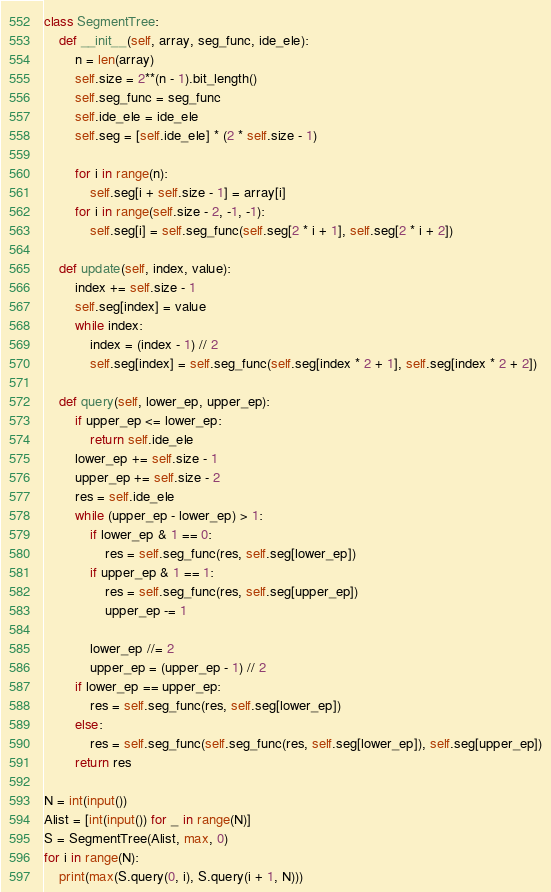<code> <loc_0><loc_0><loc_500><loc_500><_Python_>class SegmentTree:
    def __init__(self, array, seg_func, ide_ele):
        n = len(array)
        self.size = 2**(n - 1).bit_length()
        self.seg_func = seg_func
        self.ide_ele = ide_ele
        self.seg = [self.ide_ele] * (2 * self.size - 1)

        for i in range(n):
            self.seg[i + self.size - 1] = array[i]
        for i in range(self.size - 2, -1, -1):
            self.seg[i] = self.seg_func(self.seg[2 * i + 1], self.seg[2 * i + 2])

    def update(self, index, value):
        index += self.size - 1
        self.seg[index] = value
        while index:
            index = (index - 1) // 2
            self.seg[index] = self.seg_func(self.seg[index * 2 + 1], self.seg[index * 2 + 2])

    def query(self, lower_ep, upper_ep):
        if upper_ep <= lower_ep:
            return self.ide_ele
        lower_ep += self.size - 1
        upper_ep += self.size - 2
        res = self.ide_ele
        while (upper_ep - lower_ep) > 1:
            if lower_ep & 1 == 0:
                res = self.seg_func(res, self.seg[lower_ep])
            if upper_ep & 1 == 1:
                res = self.seg_func(res, self.seg[upper_ep])
                upper_ep -= 1

            lower_ep //= 2
            upper_ep = (upper_ep - 1) // 2
        if lower_ep == upper_ep:
            res = self.seg_func(res, self.seg[lower_ep])
        else:
            res = self.seg_func(self.seg_func(res, self.seg[lower_ep]), self.seg[upper_ep])
        return res

N = int(input())
Alist = [int(input()) for _ in range(N)]
S = SegmentTree(Alist, max, 0)
for i in range(N):
    print(max(S.query(0, i), S.query(i + 1, N)))
</code> 